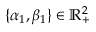<formula> <loc_0><loc_0><loc_500><loc_500>\{ \alpha _ { 1 } , \beta _ { 1 } \} \in \mathbb { R } _ { + } ^ { 2 }</formula> 